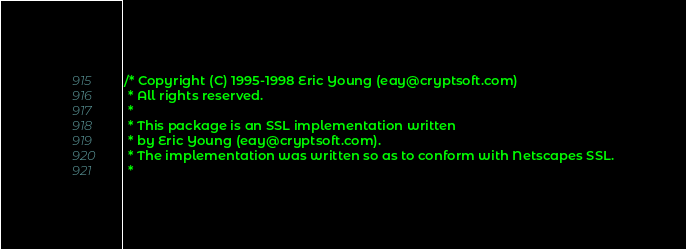<code> <loc_0><loc_0><loc_500><loc_500><_C_>/* Copyright (C) 1995-1998 Eric Young (eay@cryptsoft.com)
 * All rights reserved.
 *
 * This package is an SSL implementation written
 * by Eric Young (eay@cryptsoft.com).
 * The implementation was written so as to conform with Netscapes SSL.
 *</code> 